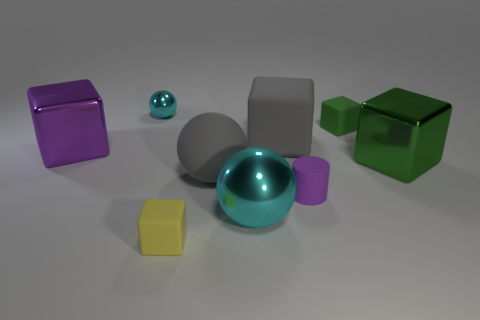Subtract all gray cubes. How many cubes are left? 4 Subtract all gray blocks. How many blocks are left? 4 Subtract all yellow cubes. Subtract all green balls. How many cubes are left? 4 Add 1 cyan things. How many objects exist? 10 Subtract all cylinders. How many objects are left? 8 Subtract 0 red spheres. How many objects are left? 9 Subtract all large green shiny blocks. Subtract all green rubber cubes. How many objects are left? 7 Add 3 tiny green rubber blocks. How many tiny green rubber blocks are left? 4 Add 9 green metal cylinders. How many green metal cylinders exist? 9 